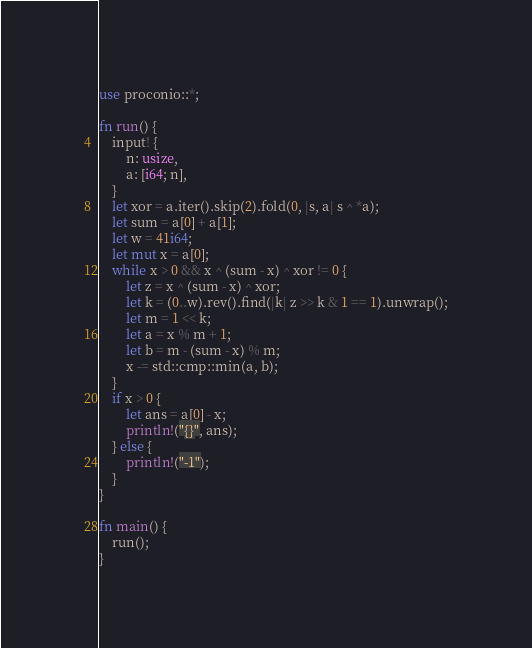<code> <loc_0><loc_0><loc_500><loc_500><_Rust_>use proconio::*;

fn run() {
    input! {
        n: usize,
        a: [i64; n],
    }
    let xor = a.iter().skip(2).fold(0, |s, a| s ^ *a);
    let sum = a[0] + a[1];
    let w = 41i64;
    let mut x = a[0];
    while x > 0 && x ^ (sum - x) ^ xor != 0 {
        let z = x ^ (sum - x) ^ xor;
        let k = (0..w).rev().find(|k| z >> k & 1 == 1).unwrap();
        let m = 1 << k;
        let a = x % m + 1;
        let b = m - (sum - x) % m;
        x -= std::cmp::min(a, b);
    }
    if x > 0 {
        let ans = a[0] - x;
        println!("{}", ans);
    } else {
        println!("-1");
    }
}

fn main() {
    run();
}
</code> 